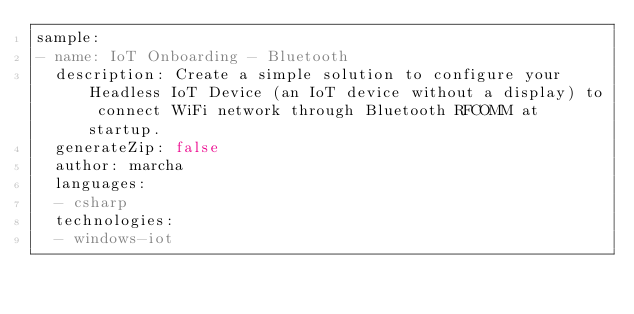Convert code to text. <code><loc_0><loc_0><loc_500><loc_500><_YAML_>sample:
- name: IoT Onboarding - Bluetooth
  description: Create a simple solution to configure your Headless IoT Device (an IoT device without a display) to connect WiFi network through Bluetooth RFCOMM at startup.
  generateZip: false
  author: marcha
  languages:
  - csharp
  technologies:
  - windows-iot</code> 